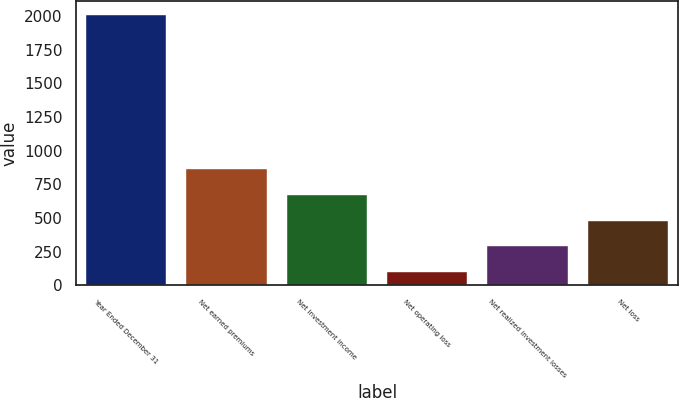Convert chart to OTSL. <chart><loc_0><loc_0><loc_500><loc_500><bar_chart><fcel>Year Ended December 31<fcel>Net earned premiums<fcel>Net investment income<fcel>Net operating loss<fcel>Net realized investment losses<fcel>Net loss<nl><fcel>2008<fcel>861.4<fcel>670.3<fcel>97<fcel>288.1<fcel>479.2<nl></chart> 